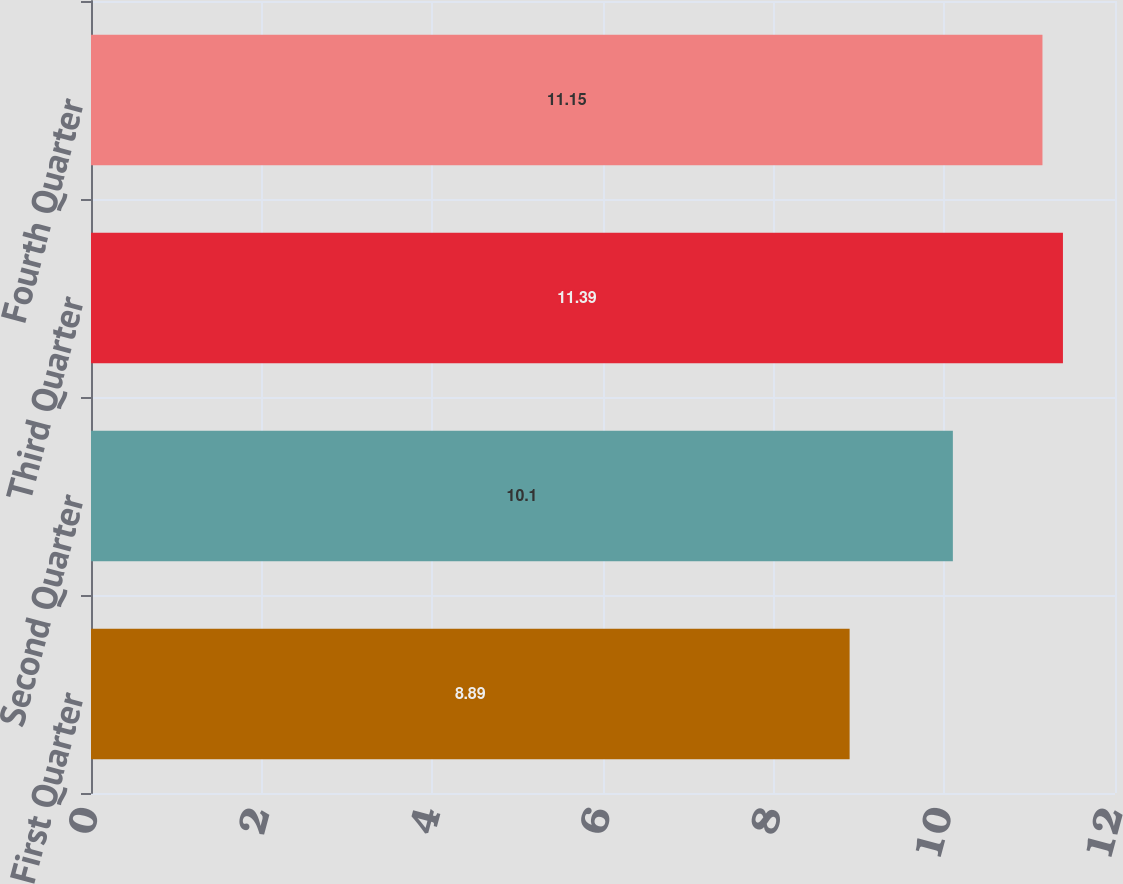Convert chart to OTSL. <chart><loc_0><loc_0><loc_500><loc_500><bar_chart><fcel>First Quarter<fcel>Second Quarter<fcel>Third Quarter<fcel>Fourth Quarter<nl><fcel>8.89<fcel>10.1<fcel>11.39<fcel>11.15<nl></chart> 